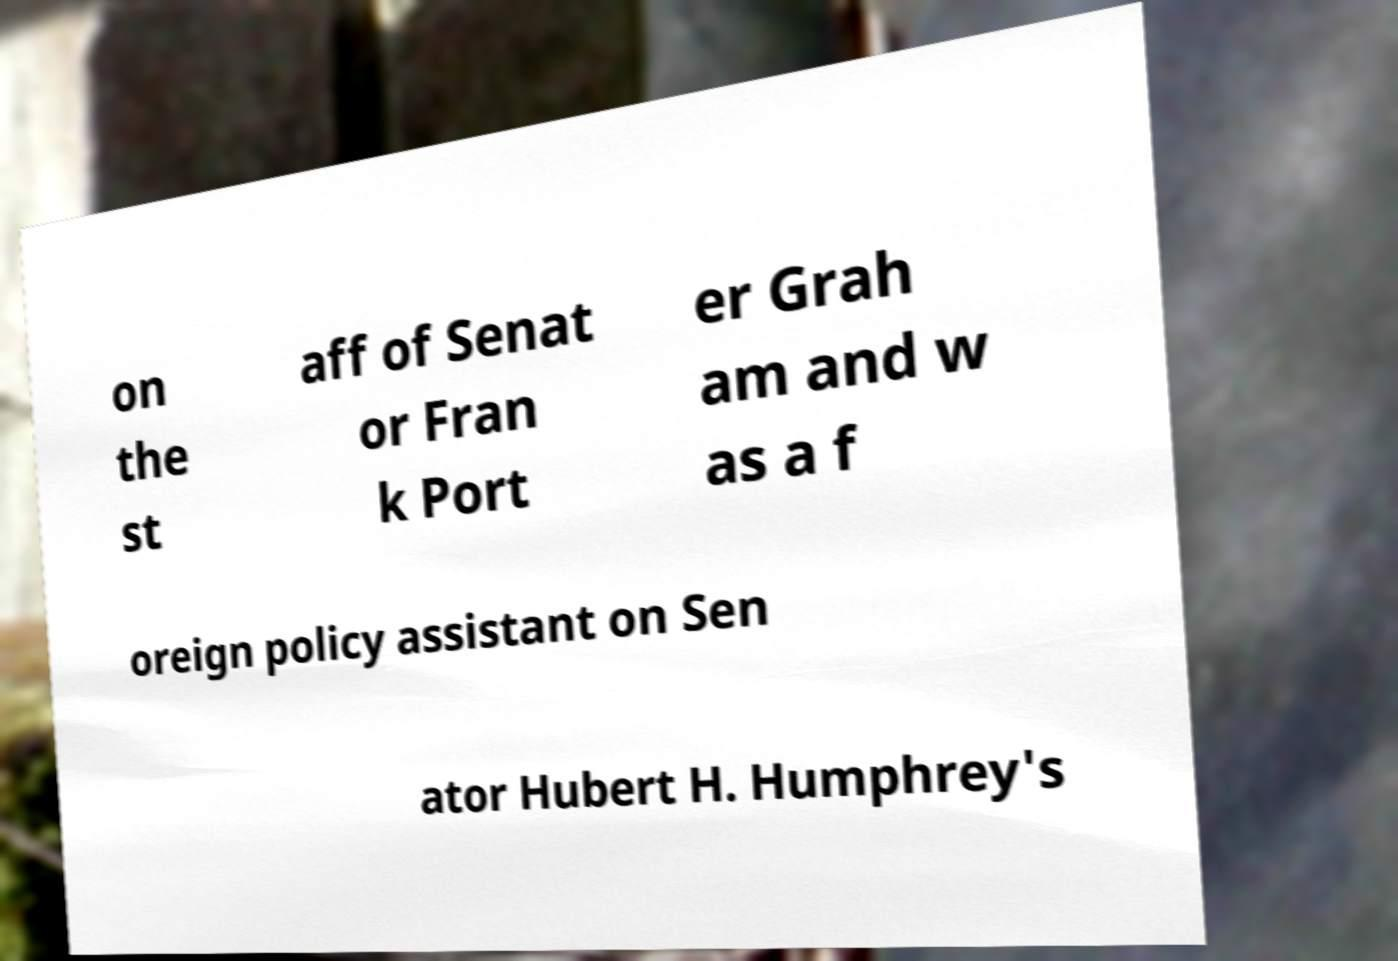Can you accurately transcribe the text from the provided image for me? on the st aff of Senat or Fran k Port er Grah am and w as a f oreign policy assistant on Sen ator Hubert H. Humphrey's 